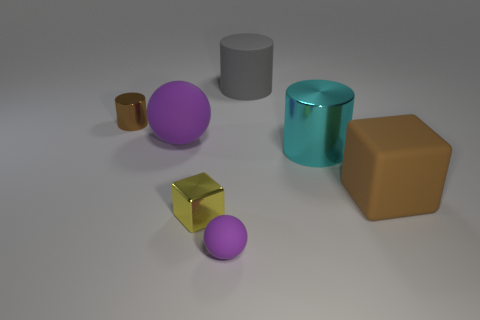How many purple spheres must be subtracted to get 1 purple spheres? 1 Add 2 big metallic objects. How many objects exist? 9 Subtract all cylinders. How many objects are left? 4 Add 4 tiny yellow blocks. How many tiny yellow blocks are left? 5 Add 2 small blue metallic balls. How many small blue metallic balls exist? 2 Subtract 0 gray blocks. How many objects are left? 7 Subtract all green matte things. Subtract all small yellow metal things. How many objects are left? 6 